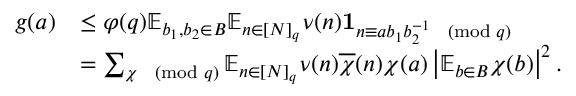Convert formula to latex. <formula><loc_0><loc_0><loc_500><loc_500>\begin{array} { r l } { g ( a ) } & { \leq \varphi ( q ) \mathbb { E } _ { b _ { 1 } , b _ { 2 } \in B } \mathbb { E } _ { n \in [ N ] _ { q } } \nu ( n ) 1 _ { n \equiv a b _ { 1 } b _ { 2 } ^ { - 1 } \pmod { q } } } \\ & { = \sum _ { \chi \pmod { q } } \mathbb { E } _ { n \in [ N ] _ { q } } \nu ( n ) \overline { \chi } ( n ) \chi ( a ) \left | \mathbb { E } _ { b \in B } \chi ( b ) \right | ^ { 2 } . } \end{array}</formula> 